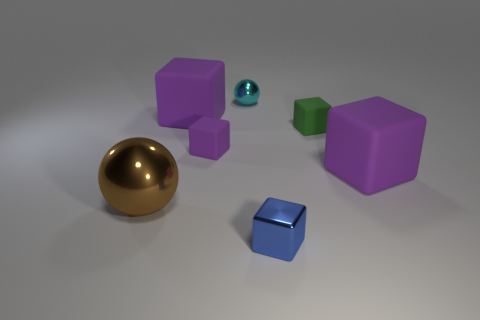There is a blue thing; what shape is it?
Your answer should be very brief. Cube. What color is the tiny metal thing that is behind the purple block that is right of the green matte block?
Keep it short and to the point. Cyan. There is a purple rubber block that is behind the small purple rubber object; what is its size?
Make the answer very short. Large. Is there a big object that has the same material as the small cyan ball?
Your answer should be compact. Yes. How many rubber things have the same shape as the big metal object?
Your response must be concise. 0. There is a large rubber object that is to the right of the large cube behind the tiny rubber block that is in front of the tiny green rubber thing; what is its shape?
Your response must be concise. Cube. What is the material of the thing that is both on the left side of the small purple thing and to the right of the brown metal ball?
Provide a short and direct response. Rubber. There is a metal object that is right of the cyan shiny object; is it the same size as the tiny purple rubber cube?
Give a very brief answer. Yes. Is there anything else that is the same size as the green rubber block?
Offer a terse response. Yes. Is the number of big cubes that are in front of the large brown ball greater than the number of purple rubber cubes that are on the left side of the small shiny cube?
Provide a succinct answer. No. 